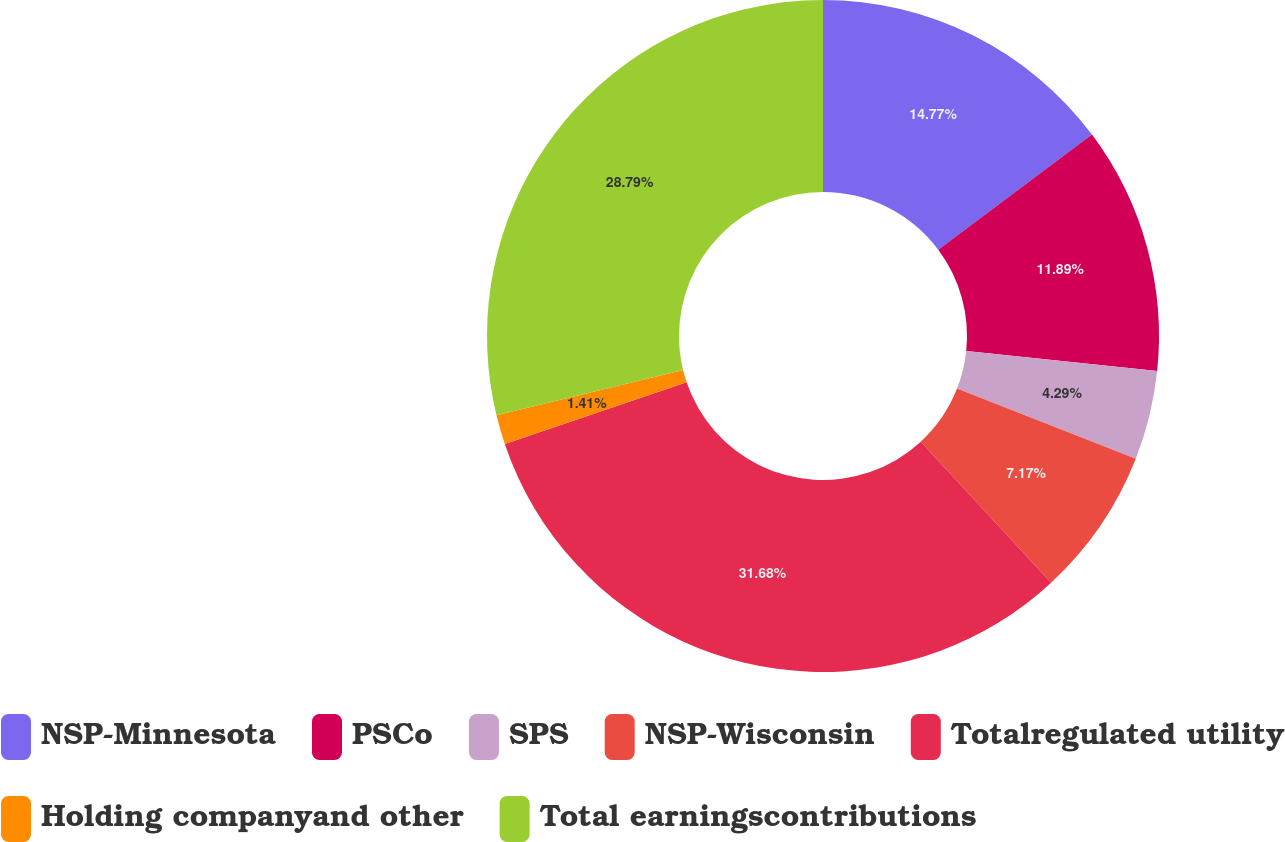<chart> <loc_0><loc_0><loc_500><loc_500><pie_chart><fcel>NSP-Minnesota<fcel>PSCo<fcel>SPS<fcel>NSP-Wisconsin<fcel>Totalregulated utility<fcel>Holding companyand other<fcel>Total earningscontributions<nl><fcel>14.77%<fcel>11.89%<fcel>4.29%<fcel>7.17%<fcel>31.67%<fcel>1.41%<fcel>28.79%<nl></chart> 